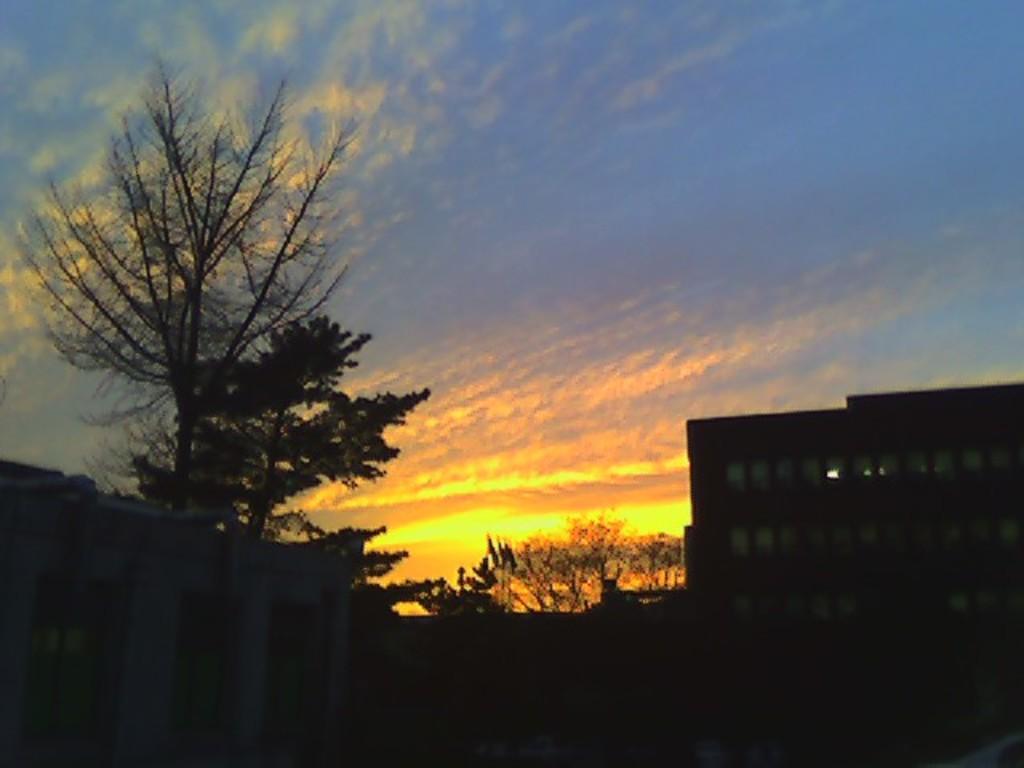How would you summarize this image in a sentence or two? This picture is clicked outside. On the left we can see a building and the trees. On the right there is a building. In the background there is a sky and the trees. 